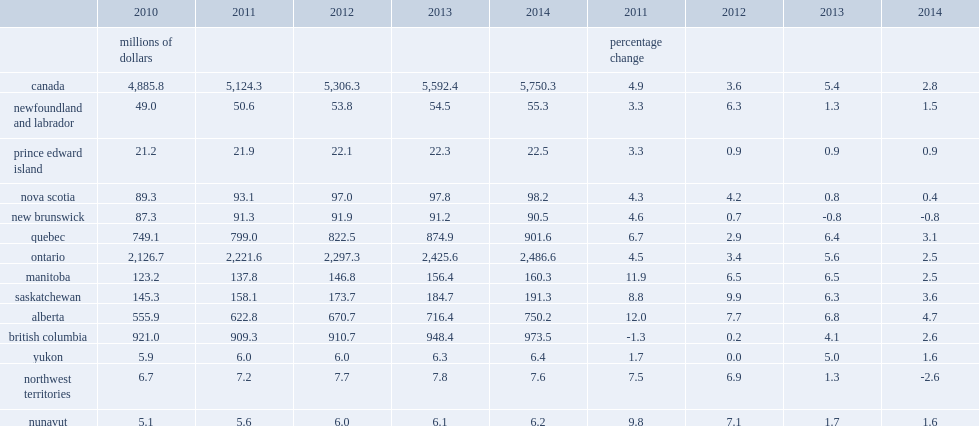What was the percentgae of sport gdp increased in all provinces and territories except northwest territories? -2.6. What was the percentgae of sport gdp increased in all provinces and territories except new brunswick? -0.8. What was the percentgae of sport gdp increased in all provinces and territories in alberta? 4.7. What was the percentage of sport gdp in newfoundland and labrador increased in 2014? 1.5. What was the percentage of sport gdp in newfoundland and labrador increased in 2013? 1.3. What was the percentage of sport gdp in canada rose in 2014? 2.8. What was the percentage of sport gdp in canada rose in 2013? 5.4. What was the percentage of sport gdp in prince edward island rose in 2014, the same pace as the previous two years? 0.9. What was the percentage of sport gdp in nova scotia rose in 2014? 0.4. What was the percentage of sport gdp in nova scotia rose in 2013? 0.8. What was the percentage of sport gdp in new brunswick decreased in 2014 following a similar decline in 2013? 0.8. What was the percentgae of sport gdp in quebec rose in 2014? 3.1. What was the percentgae of sport gdp in quebec rose in 2013? 6.4. What was the percentage of sport gdp in ontario rose in 2014? 2.5. What was the percentage of sport gdp in ontario rose in 2013? 5.6. What was the percentage of sport gdp in manitoba rose in 2014? 2.5. What was the percentage of sport gdp in manitoba rose in 2013? 6.5. What was the percentage of sport gdp in saskatchewan rose in 2014? 3.6. What was the percentage of sport gdp in saskatchewan rose in 2013? 6.3. What was the percentage of sport gdp in alberta rose in 2014? 4.7. What was the percentage of sport gdp in british colubia rose in 2014? 2.6. What was the percentage of sport gdp in british colubia rose in 2013? 4.1. What was the percentage of sport gdp in yukon rose in 2014? 1.6. What was the percentage of sport gdp in yukon rose in 2013? 5.0. What was the percentage of sport gdp in northwest territories rose in 2014? 2.6. What was the percentage of sport gdp in northwest territories rose in 2013? 1.3. What was the percentage of sport gdp in nunavut increased in 2014? 1.6. What was the percentage of sport gdp in nunavut increased in 2013? 1.7. 